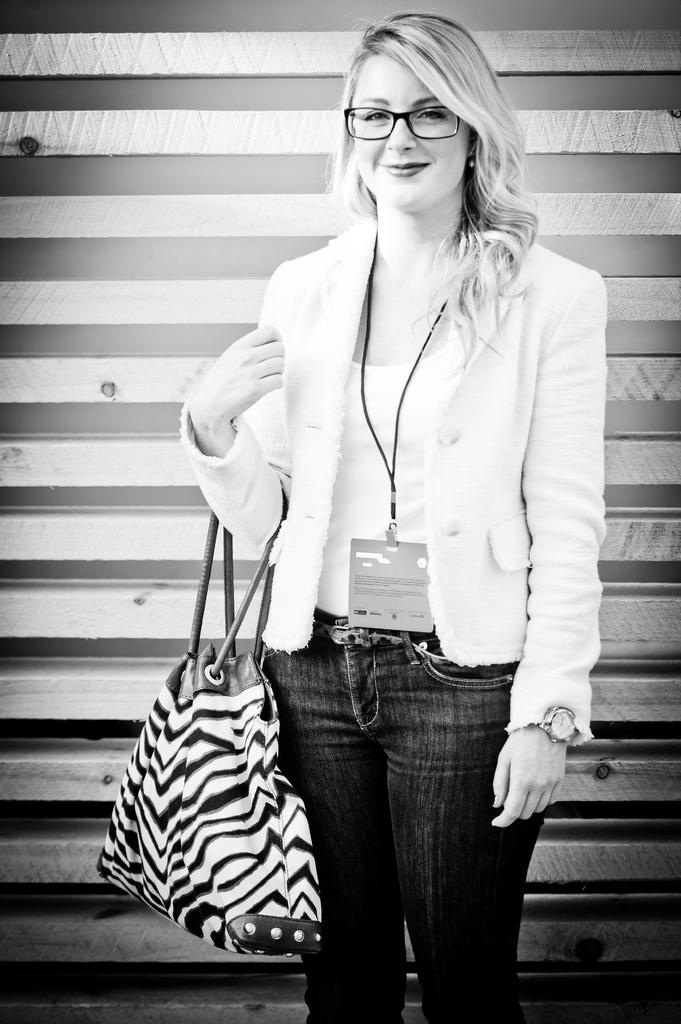Who is the main subject in the image? There is a woman in the image. What is the woman wearing on her upper body? The woman is wearing a white t-shirt. Can you describe the woman's handbag? The woman is wearing a handbag with white and black colors. What is the woman doing with her handbag? The woman is holding the handbag. What is the woman's facial expression? The woman is smiling. What accessory is the woman wearing on her face? The woman is wearing spectacles. How many legs does the stick have in the image? There is no stick present in the image, so it is not possible to determine the number of legs it might have. 